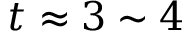<formula> <loc_0><loc_0><loc_500><loc_500>t \approx 3 \sim 4</formula> 